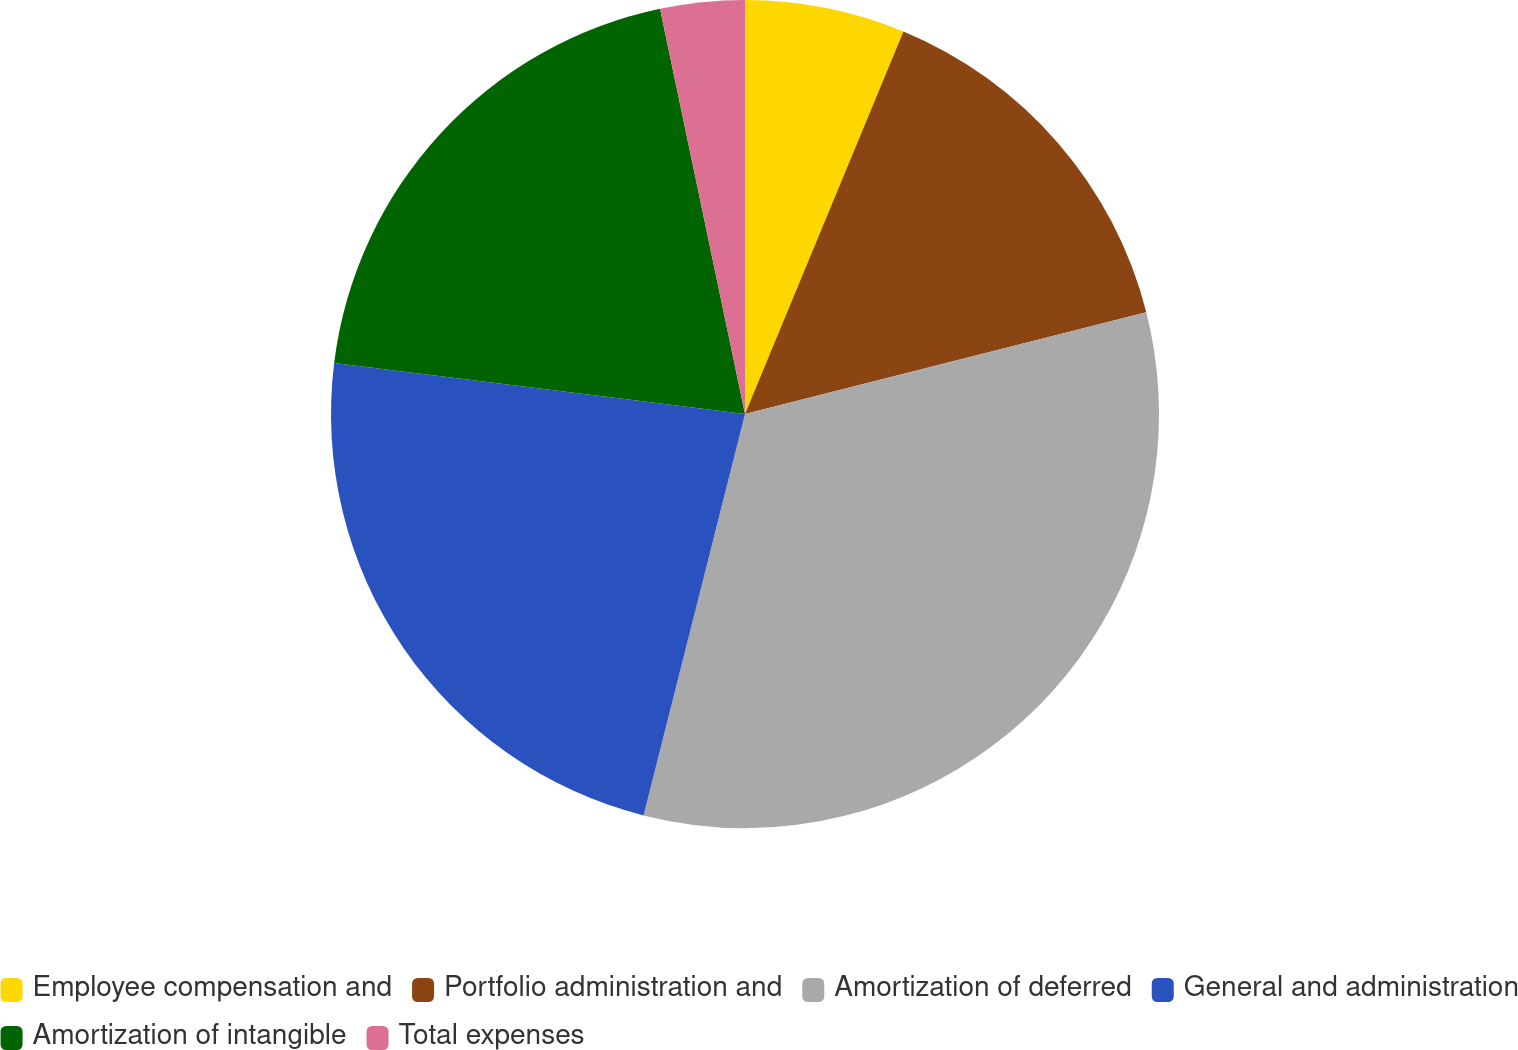Convert chart to OTSL. <chart><loc_0><loc_0><loc_500><loc_500><pie_chart><fcel>Employee compensation and<fcel>Portfolio administration and<fcel>Amortization of deferred<fcel>General and administration<fcel>Amortization of intangible<fcel>Total expenses<nl><fcel>6.25%<fcel>14.8%<fcel>32.89%<fcel>23.03%<fcel>19.74%<fcel>3.29%<nl></chart> 